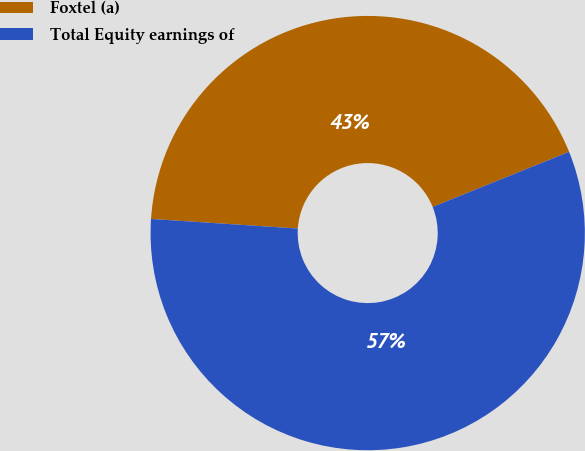Convert chart. <chart><loc_0><loc_0><loc_500><loc_500><pie_chart><fcel>Foxtel (a)<fcel>Total Equity earnings of<nl><fcel>42.86%<fcel>57.14%<nl></chart> 